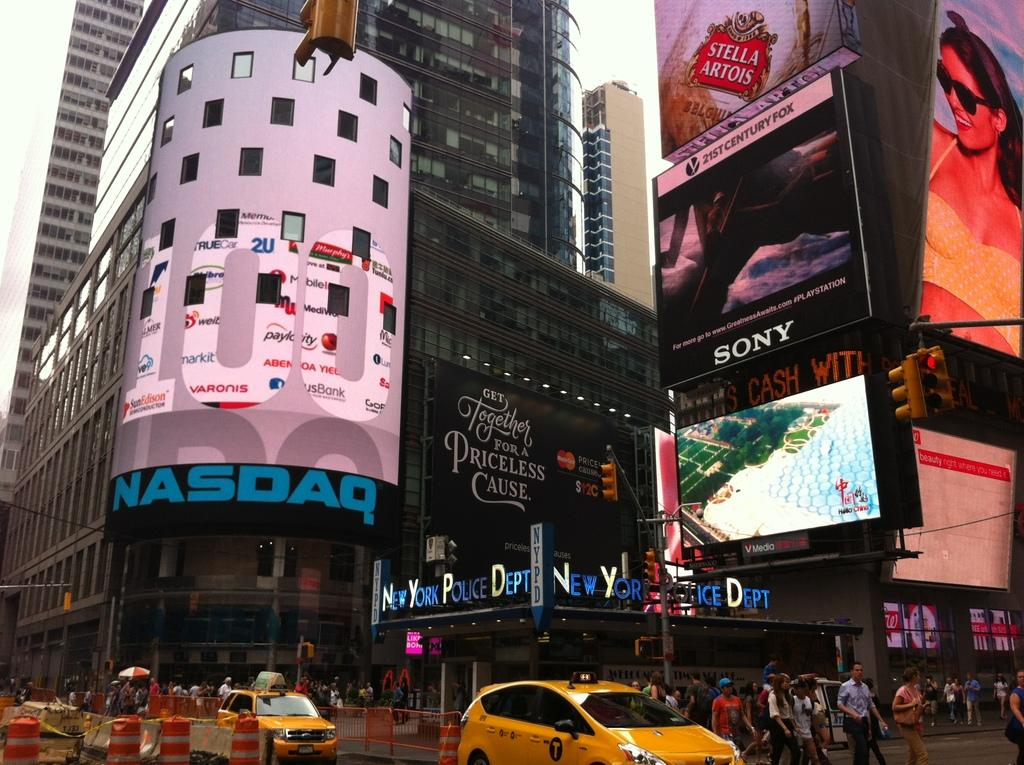<image>
Give a short and clear explanation of the subsequent image. A city street scene with the corner entrance to NASDAQ. 